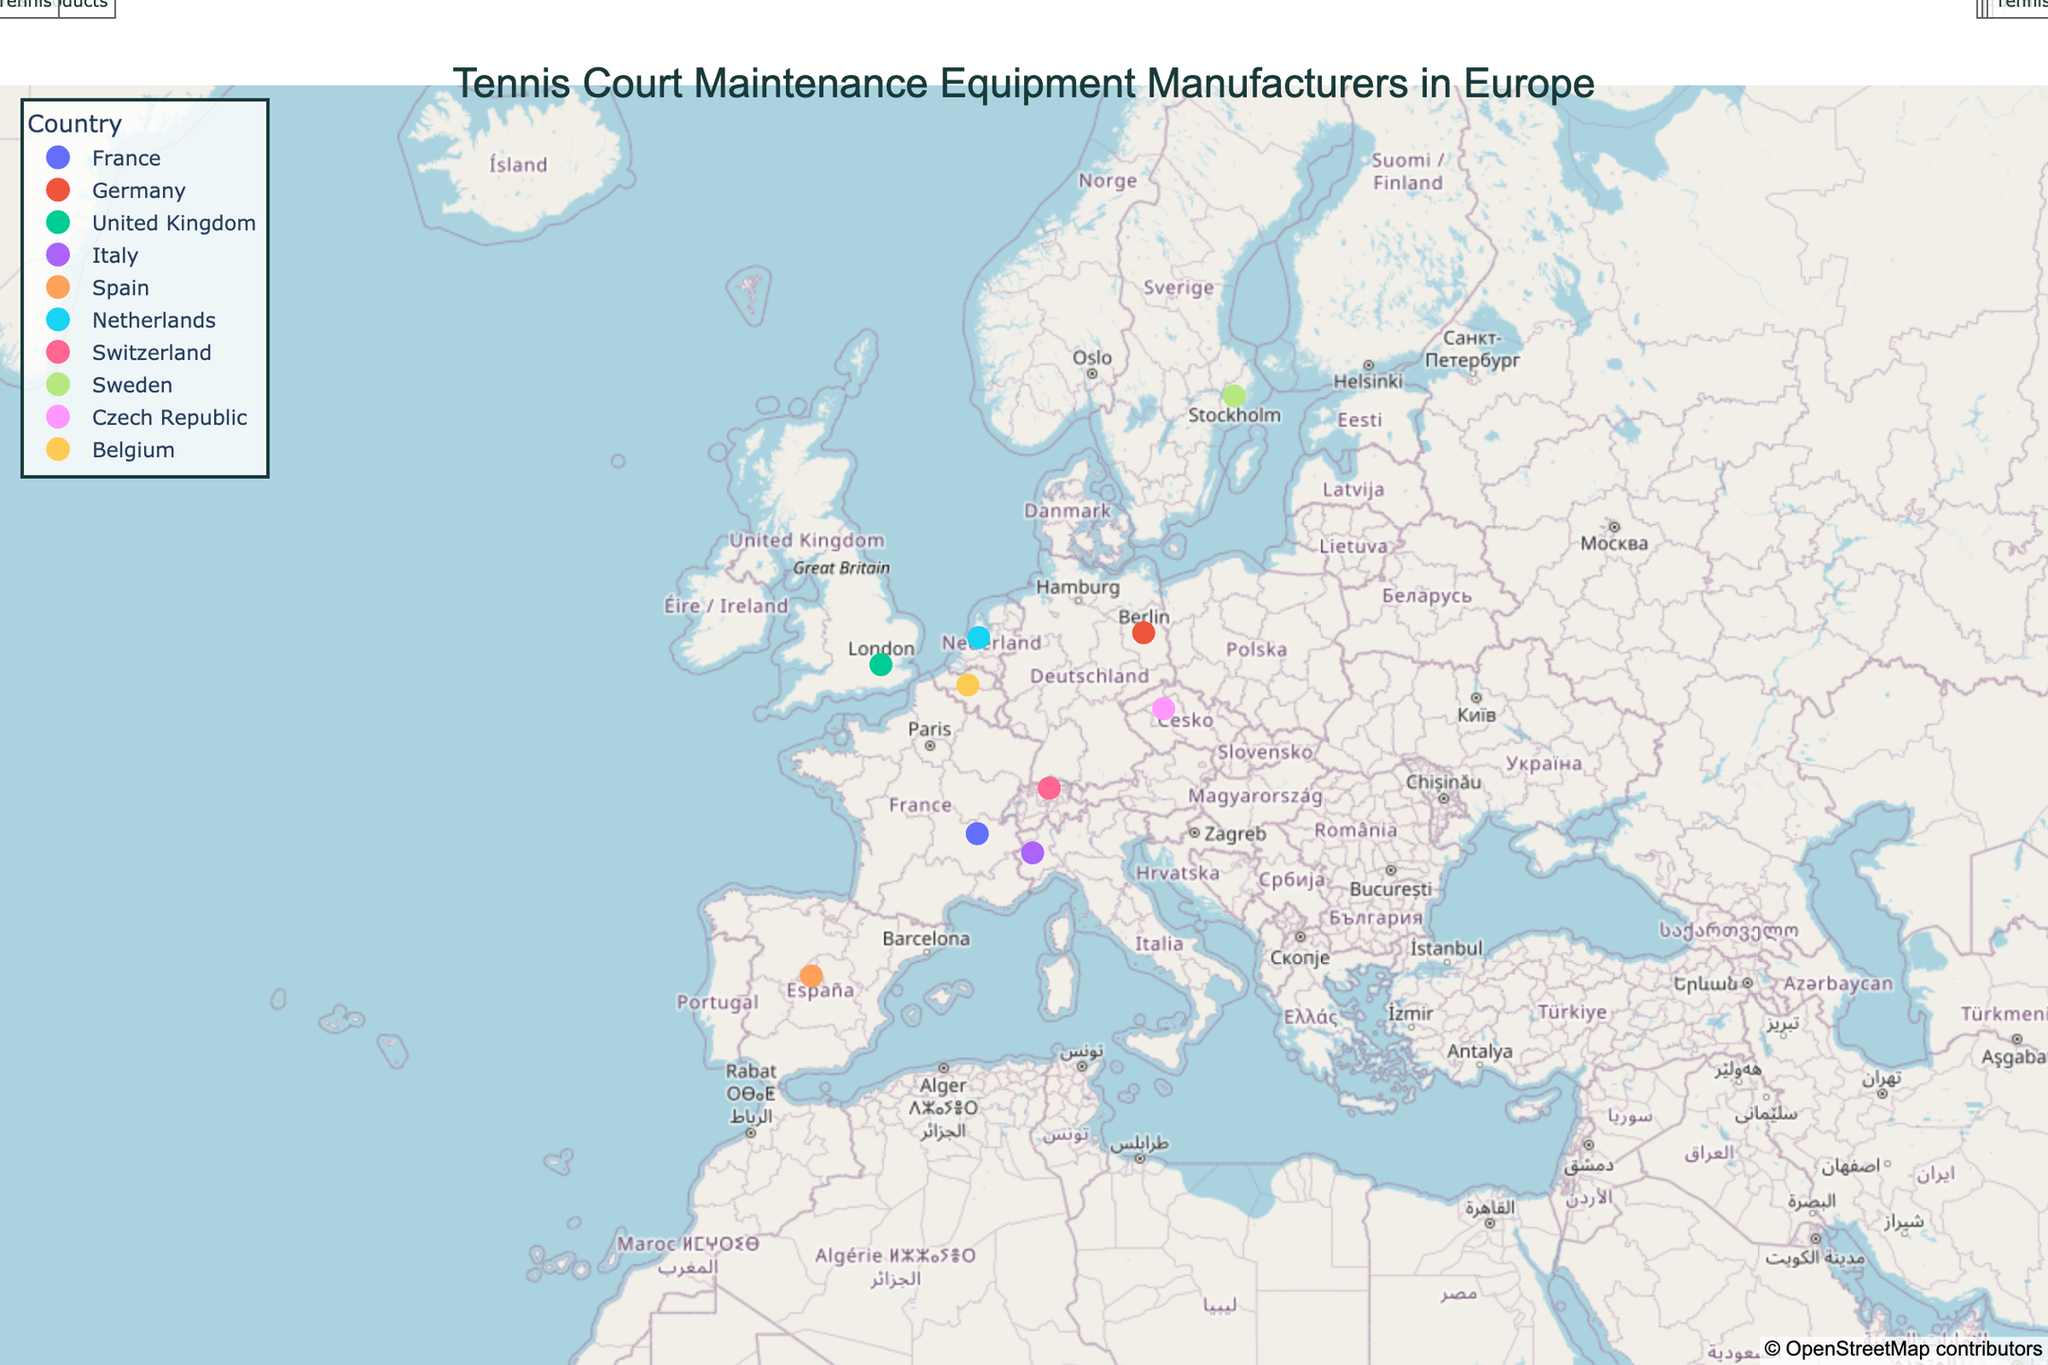What's the title of the figure? The title is usually found at the top of the figure and provides a summary of what the plot represents. In this case, it is centered at the top.
Answer: "Tennis Court Maintenance Equipment Manufacturers in Europe" Which country's company specializes in Artificial clay installation systems? By looking at the hover information when you place the cursor over the dots in Germany, you’ll find the company Amorim Sports with Artificial clay installation systems mentioned.
Answer: Germany How many countries are represented in the plot? Each color and label on the legend represents a different country. Counting all the unique countries, we find there are 10 countries listed.
Answer: 10 Which company is located at coordinates (51.5074, -0.1278)? By locating the point at latitude 51.5074 and longitude -0.1278 on the map and checking the hover information, we see that it is Edwards Sports Products.
Answer: Edwards Sports Products What's the specialty equipment for the company located in Belgium? On the plot, find the point representing Belgium and look at the hover information to see the specialty equipment, which is Court resurfacing tools.
Answer: Court resurfacing tools Which country has a company that produces Synthetic court cleaning machines? By reading the hover information for each point, we notice that the company Mondo S.p.A. in Italy specializes in Synthetic court cleaning machines.
Answer: Italy Compare the specialties of companies in France and Spain. Are they different? Looking at the hover information for the companies in France and Spain, Babolat in France specializes in Clay court rollers, while Jubo Tennis in Spain focuses on Ball machines. Thus, their specialties are different.
Answer: Yes, they are different What's the northernmost company displayed on the map, and what do they specialize in? To find the northernmost company, identify the point with the highest latitude, which is Unisport in Sweden with a latitude of 59.3293. This company specializes in Court irrigation systems.
Answer: Unisport, Court irrigation systems Is there any country that has more than one company represented? By examining each point and its associated country, we see that all countries only have one company each on this plot. Thus, no country has more than one company represented.
Answer: No Which company located in Southern Europe focuses on Ball machines? Southern Europe includes countries like Spain, Italy, etc. By examining the plot, we notice that Jubo Tennis in Spain, located in Southern Europe, focuses on Ball machines.
Answer: Jubo Tennis 